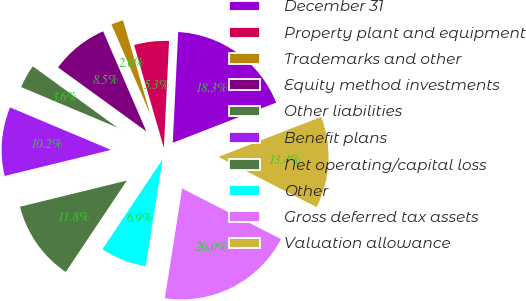Convert chart. <chart><loc_0><loc_0><loc_500><loc_500><pie_chart><fcel>December 31<fcel>Property plant and equipment<fcel>Trademarks and other<fcel>Equity method investments<fcel>Other liabilities<fcel>Benefit plans<fcel>Net operating/capital loss<fcel>Other<fcel>Gross deferred tax assets<fcel>Valuation allowance<nl><fcel>18.32%<fcel>5.27%<fcel>2.0%<fcel>8.53%<fcel>3.64%<fcel>10.16%<fcel>11.8%<fcel>6.9%<fcel>19.95%<fcel>13.43%<nl></chart> 